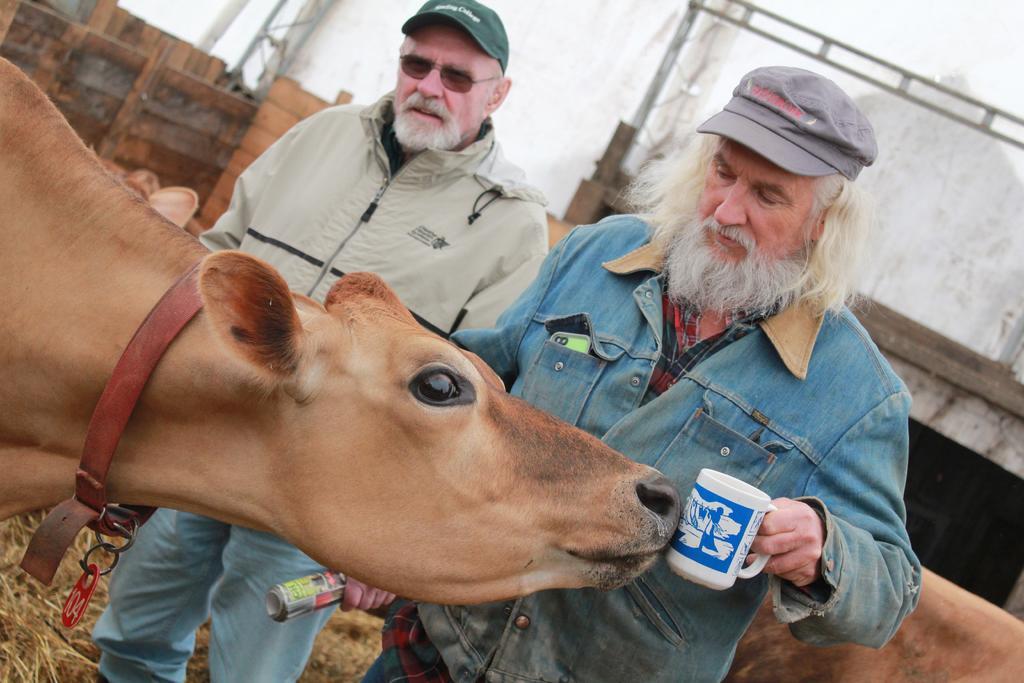Can you describe this image briefly? In this image there is an animal. Behind there are two people standing on the land having some grass. Right side there is a person holding a cup in his hand. He is wearing a cap. Beside him there is a person holding a paper. He is wearing goggles and cap. There are animals on the land. Background there is a wall. 